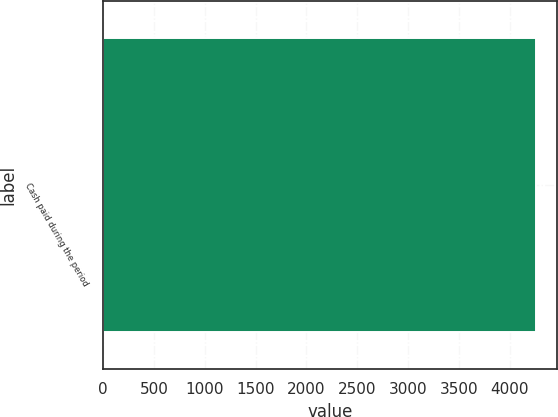Convert chart to OTSL. <chart><loc_0><loc_0><loc_500><loc_500><bar_chart><fcel>Cash paid during the period<nl><fcel>4257<nl></chart> 